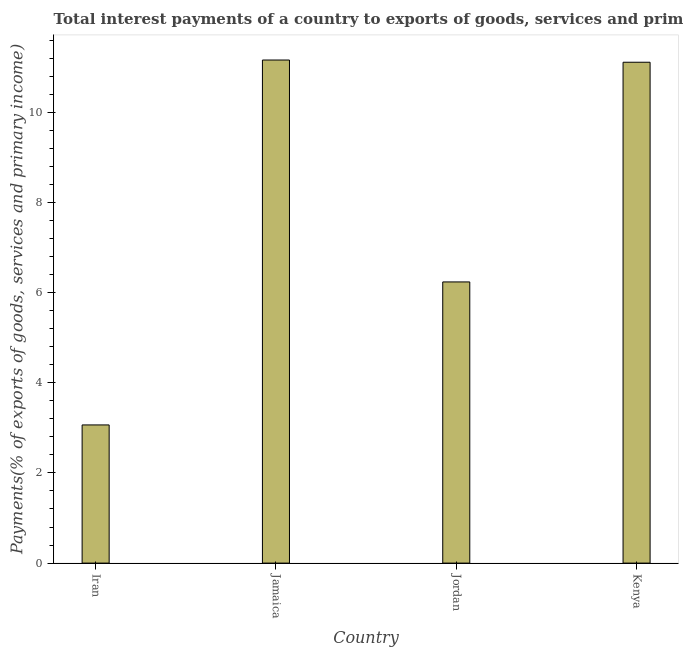What is the title of the graph?
Offer a very short reply. Total interest payments of a country to exports of goods, services and primary income in 1980. What is the label or title of the X-axis?
Provide a short and direct response. Country. What is the label or title of the Y-axis?
Keep it short and to the point. Payments(% of exports of goods, services and primary income). What is the total interest payments on external debt in Jordan?
Keep it short and to the point. 6.24. Across all countries, what is the maximum total interest payments on external debt?
Ensure brevity in your answer.  11.16. Across all countries, what is the minimum total interest payments on external debt?
Provide a short and direct response. 3.06. In which country was the total interest payments on external debt maximum?
Ensure brevity in your answer.  Jamaica. In which country was the total interest payments on external debt minimum?
Provide a short and direct response. Iran. What is the sum of the total interest payments on external debt?
Your answer should be very brief. 31.57. What is the difference between the total interest payments on external debt in Jordan and Kenya?
Your answer should be very brief. -4.87. What is the average total interest payments on external debt per country?
Offer a very short reply. 7.89. What is the median total interest payments on external debt?
Provide a short and direct response. 8.67. In how many countries, is the total interest payments on external debt greater than 2 %?
Provide a succinct answer. 4. What is the ratio of the total interest payments on external debt in Iran to that in Jordan?
Provide a short and direct response. 0.49. What is the difference between the highest and the second highest total interest payments on external debt?
Your answer should be very brief. 0.05. Is the sum of the total interest payments on external debt in Jordan and Kenya greater than the maximum total interest payments on external debt across all countries?
Give a very brief answer. Yes. What is the difference between the highest and the lowest total interest payments on external debt?
Offer a terse response. 8.09. In how many countries, is the total interest payments on external debt greater than the average total interest payments on external debt taken over all countries?
Your answer should be very brief. 2. How many countries are there in the graph?
Ensure brevity in your answer.  4. What is the Payments(% of exports of goods, services and primary income) in Iran?
Give a very brief answer. 3.06. What is the Payments(% of exports of goods, services and primary income) in Jamaica?
Provide a succinct answer. 11.16. What is the Payments(% of exports of goods, services and primary income) in Jordan?
Your answer should be very brief. 6.24. What is the Payments(% of exports of goods, services and primary income) in Kenya?
Your response must be concise. 11.11. What is the difference between the Payments(% of exports of goods, services and primary income) in Iran and Jamaica?
Ensure brevity in your answer.  -8.09. What is the difference between the Payments(% of exports of goods, services and primary income) in Iran and Jordan?
Keep it short and to the point. -3.17. What is the difference between the Payments(% of exports of goods, services and primary income) in Iran and Kenya?
Your response must be concise. -8.04. What is the difference between the Payments(% of exports of goods, services and primary income) in Jamaica and Jordan?
Your answer should be compact. 4.92. What is the difference between the Payments(% of exports of goods, services and primary income) in Jamaica and Kenya?
Provide a succinct answer. 0.05. What is the difference between the Payments(% of exports of goods, services and primary income) in Jordan and Kenya?
Offer a terse response. -4.87. What is the ratio of the Payments(% of exports of goods, services and primary income) in Iran to that in Jamaica?
Offer a very short reply. 0.28. What is the ratio of the Payments(% of exports of goods, services and primary income) in Iran to that in Jordan?
Your answer should be very brief. 0.49. What is the ratio of the Payments(% of exports of goods, services and primary income) in Iran to that in Kenya?
Offer a terse response. 0.28. What is the ratio of the Payments(% of exports of goods, services and primary income) in Jamaica to that in Jordan?
Give a very brief answer. 1.79. What is the ratio of the Payments(% of exports of goods, services and primary income) in Jamaica to that in Kenya?
Make the answer very short. 1. What is the ratio of the Payments(% of exports of goods, services and primary income) in Jordan to that in Kenya?
Your answer should be compact. 0.56. 